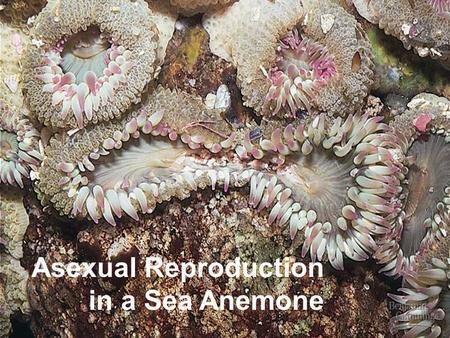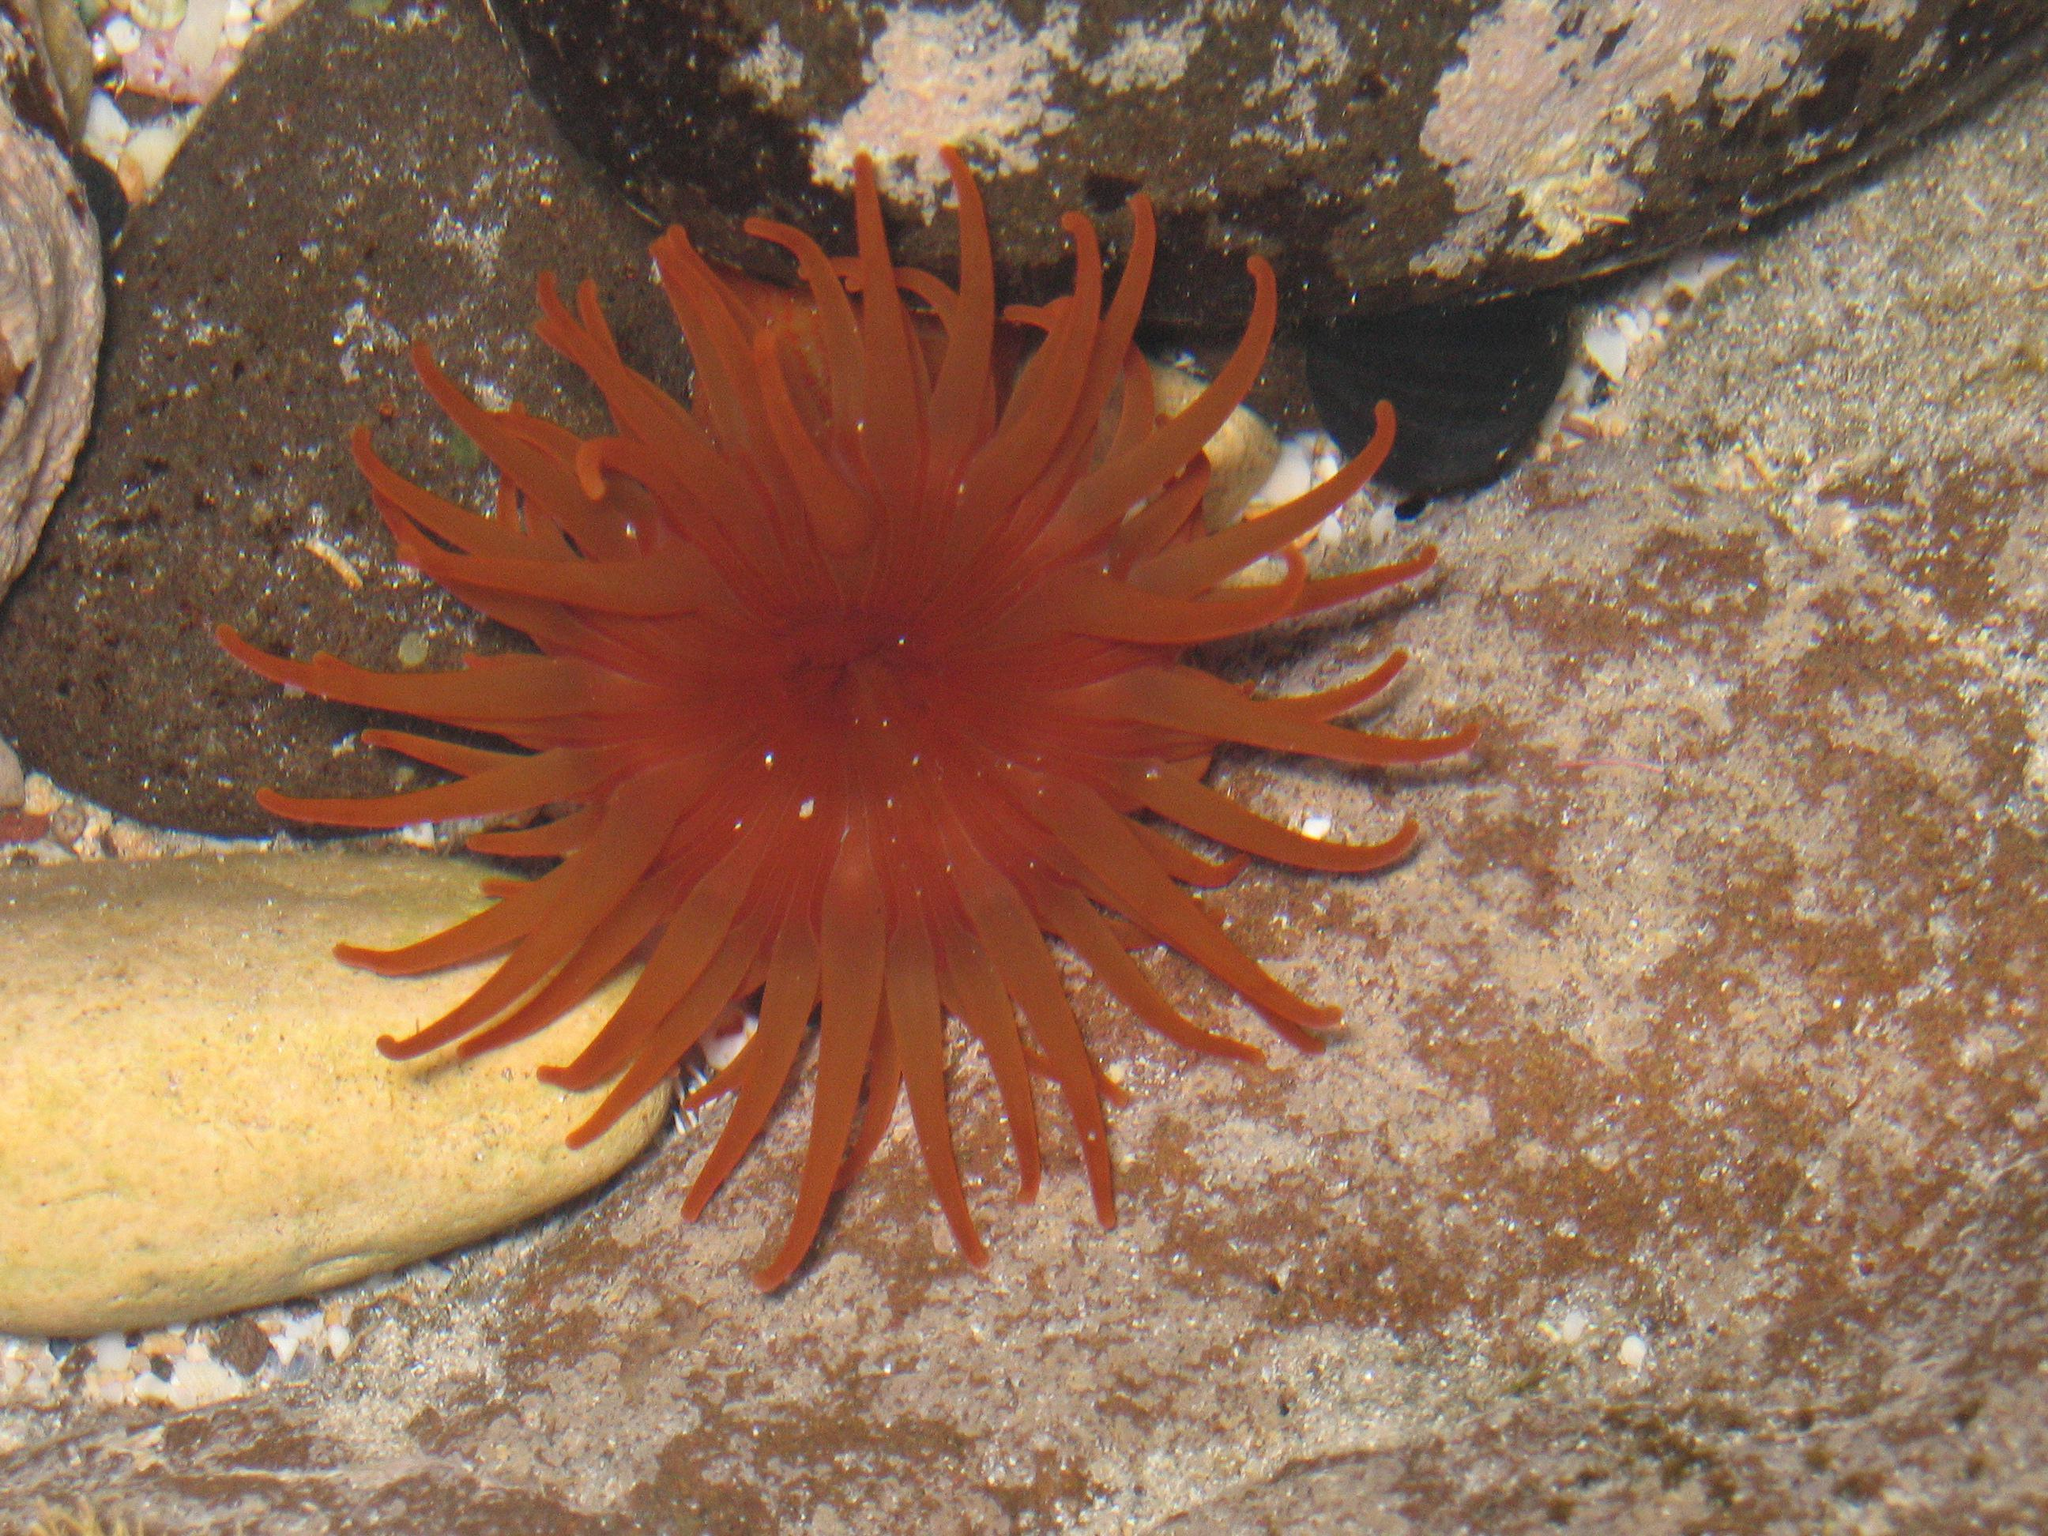The first image is the image on the left, the second image is the image on the right. For the images shown, is this caption "The right image shows a single prominent anemone with tendrils mostly spreading outward around a reddish-orange center." true? Answer yes or no. Yes. The first image is the image on the left, the second image is the image on the right. Evaluate the accuracy of this statement regarding the images: "There is one ruler visible in the image.". Is it true? Answer yes or no. No. 